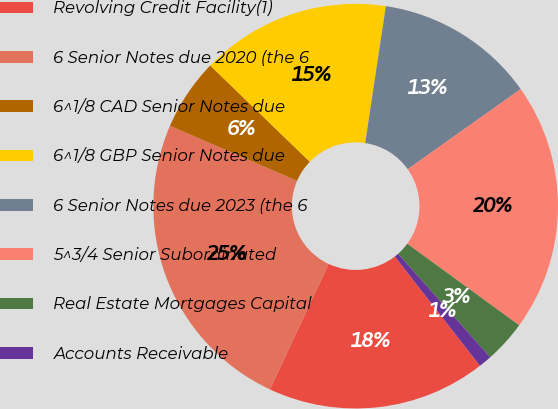Convert chart to OTSL. <chart><loc_0><loc_0><loc_500><loc_500><pie_chart><fcel>Revolving Credit Facility(1)<fcel>6 Senior Notes due 2020 (the 6<fcel>6^1/8 CAD Senior Notes due<fcel>6^1/8 GBP Senior Notes due<fcel>6 Senior Notes due 2023 (the 6<fcel>5^3/4 Senior Subordinated<fcel>Real Estate Mortgages Capital<fcel>Accounts Receivable<nl><fcel>17.5%<fcel>24.52%<fcel>5.74%<fcel>15.15%<fcel>12.8%<fcel>19.84%<fcel>3.4%<fcel>1.05%<nl></chart> 